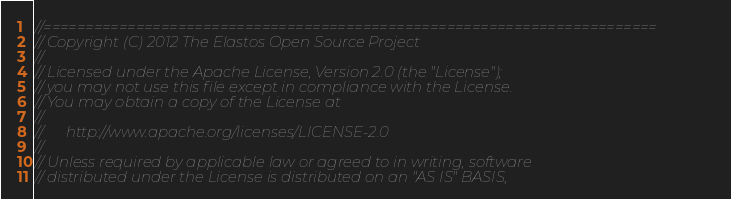Convert code to text. <code><loc_0><loc_0><loc_500><loc_500><_C_>//=========================================================================
// Copyright (C) 2012 The Elastos Open Source Project
//
// Licensed under the Apache License, Version 2.0 (the "License");
// you may not use this file except in compliance with the License.
// You may obtain a copy of the License at
//
//      http://www.apache.org/licenses/LICENSE-2.0
//
// Unless required by applicable law or agreed to in writing, software
// distributed under the License is distributed on an "AS IS" BASIS,</code> 